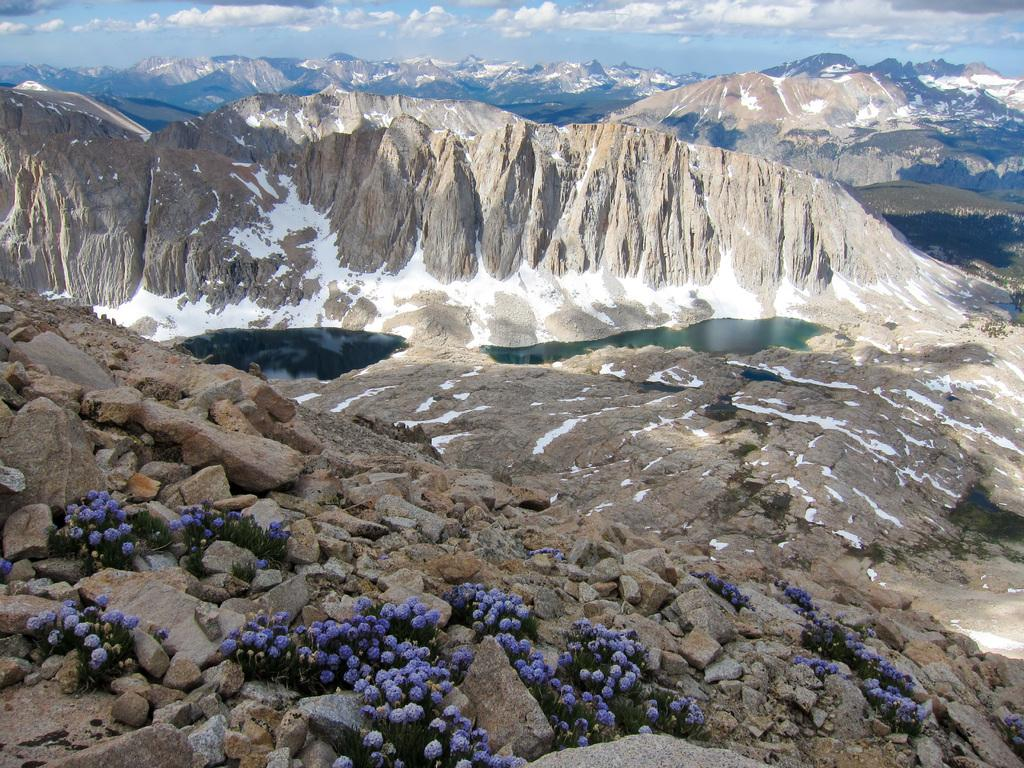What is the main feature in the middle of the picture? There is a lake in the middle of the picture. What can be seen at the bottom of the picture? There are rocks at the bottom of the picture. What is visible in the background of the picture? There are hills and clouds in the sky in the background of the picture. What type of drop can be seen falling from the clouds in the image? There is no drop falling from the clouds in the image; only the lake, rocks, hills, and clouds are present. What religious symbols can be seen in the image? There are no religious symbols present in the image. 